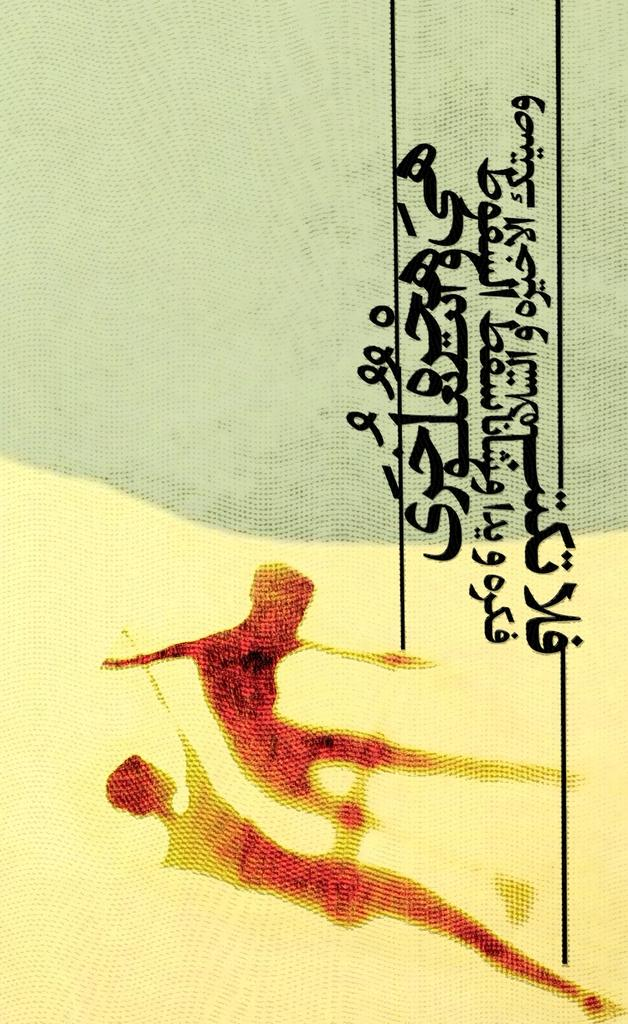What is present on the left side of the image? There is a poster in the image. What can be found on the right side of the poster? There is text on the right side of the poster. What type of liquid is being poured from the jar in the image? There is no jar or liquid present in the image; it only features a poster with text on the right side. 